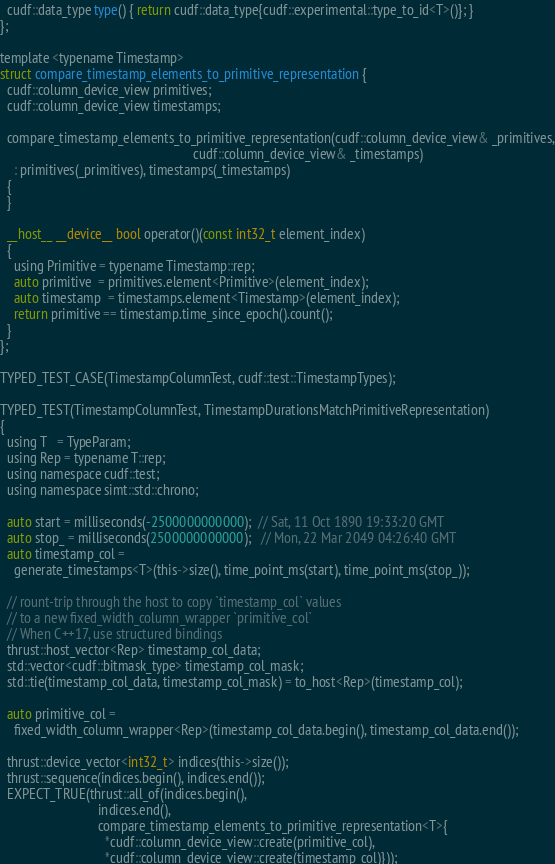<code> <loc_0><loc_0><loc_500><loc_500><_Cuda_>  cudf::data_type type() { return cudf::data_type{cudf::experimental::type_to_id<T>()}; }
};

template <typename Timestamp>
struct compare_timestamp_elements_to_primitive_representation {
  cudf::column_device_view primitives;
  cudf::column_device_view timestamps;

  compare_timestamp_elements_to_primitive_representation(cudf::column_device_view& _primitives,
                                                         cudf::column_device_view& _timestamps)
    : primitives(_primitives), timestamps(_timestamps)
  {
  }

  __host__ __device__ bool operator()(const int32_t element_index)
  {
    using Primitive = typename Timestamp::rep;
    auto primitive  = primitives.element<Primitive>(element_index);
    auto timestamp  = timestamps.element<Timestamp>(element_index);
    return primitive == timestamp.time_since_epoch().count();
  }
};

TYPED_TEST_CASE(TimestampColumnTest, cudf::test::TimestampTypes);

TYPED_TEST(TimestampColumnTest, TimestampDurationsMatchPrimitiveRepresentation)
{
  using T   = TypeParam;
  using Rep = typename T::rep;
  using namespace cudf::test;
  using namespace simt::std::chrono;

  auto start = milliseconds(-2500000000000);  // Sat, 11 Oct 1890 19:33:20 GMT
  auto stop_ = milliseconds(2500000000000);   // Mon, 22 Mar 2049 04:26:40 GMT
  auto timestamp_col =
    generate_timestamps<T>(this->size(), time_point_ms(start), time_point_ms(stop_));

  // rount-trip through the host to copy `timestamp_col` values
  // to a new fixed_width_column_wrapper `primitive_col`
  // When C++17, use structured bindings
  thrust::host_vector<Rep> timestamp_col_data;
  std::vector<cudf::bitmask_type> timestamp_col_mask;
  std::tie(timestamp_col_data, timestamp_col_mask) = to_host<Rep>(timestamp_col);

  auto primitive_col =
    fixed_width_column_wrapper<Rep>(timestamp_col_data.begin(), timestamp_col_data.end());

  thrust::device_vector<int32_t> indices(this->size());
  thrust::sequence(indices.begin(), indices.end());
  EXPECT_TRUE(thrust::all_of(indices.begin(),
                             indices.end(),
                             compare_timestamp_elements_to_primitive_representation<T>{
                               *cudf::column_device_view::create(primitive_col),
                               *cudf::column_device_view::create(timestamp_col)}));</code> 